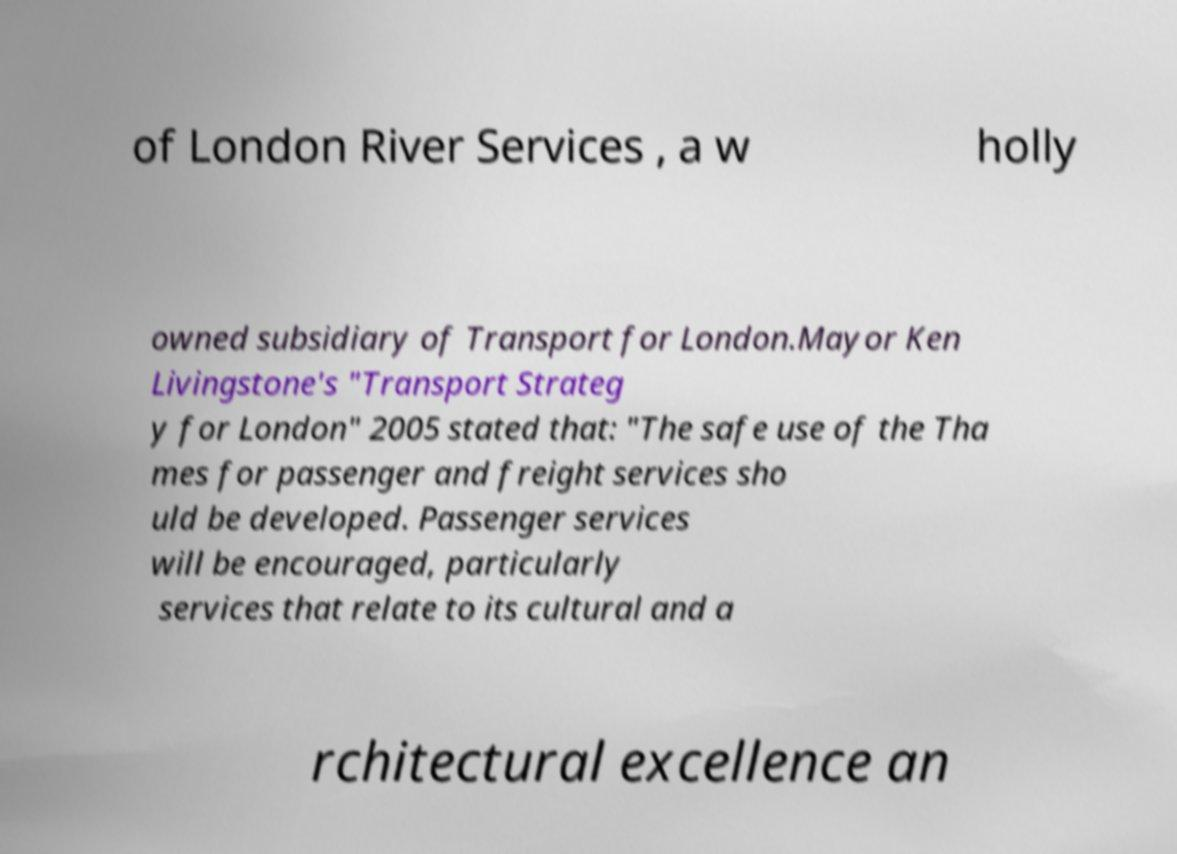Please identify and transcribe the text found in this image. of London River Services , a w holly owned subsidiary of Transport for London.Mayor Ken Livingstone's "Transport Strateg y for London" 2005 stated that: "The safe use of the Tha mes for passenger and freight services sho uld be developed. Passenger services will be encouraged, particularly services that relate to its cultural and a rchitectural excellence an 